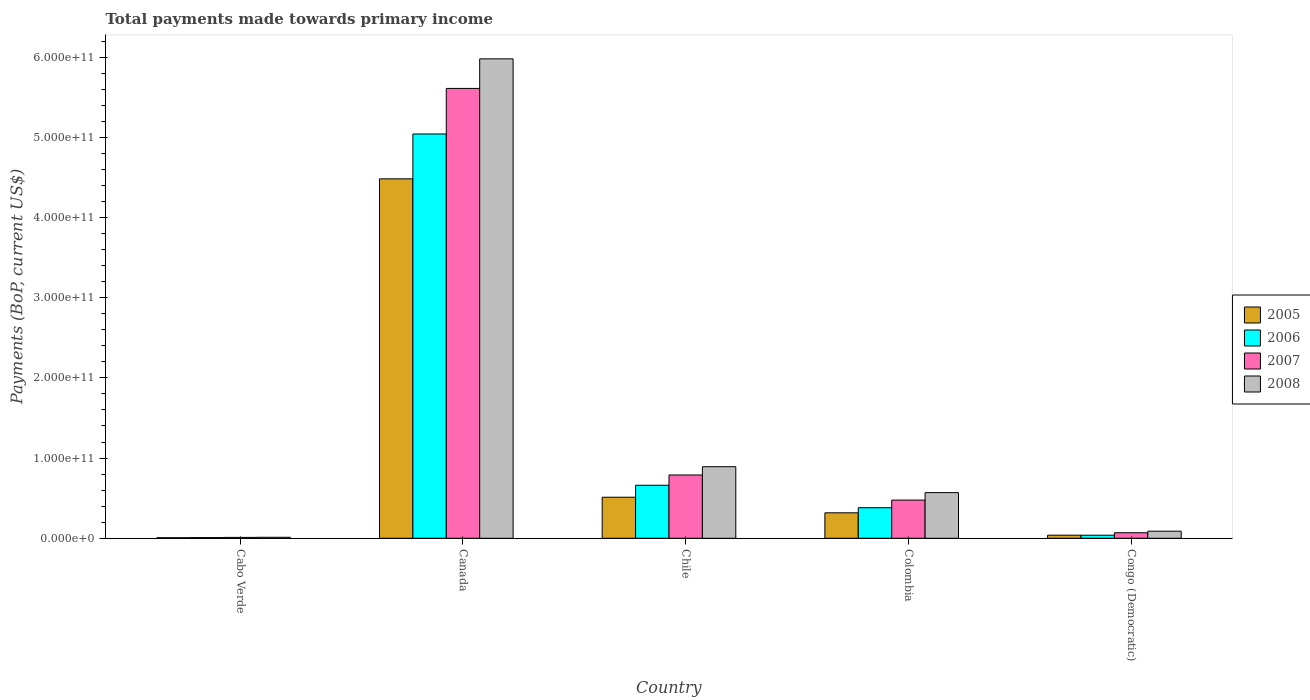How many different coloured bars are there?
Your answer should be very brief. 4. Are the number of bars per tick equal to the number of legend labels?
Ensure brevity in your answer.  Yes. How many bars are there on the 5th tick from the right?
Offer a very short reply. 4. What is the label of the 1st group of bars from the left?
Make the answer very short. Cabo Verde. What is the total payments made towards primary income in 2007 in Canada?
Offer a terse response. 5.61e+11. Across all countries, what is the maximum total payments made towards primary income in 2007?
Offer a very short reply. 5.61e+11. Across all countries, what is the minimum total payments made towards primary income in 2007?
Keep it short and to the point. 1.09e+09. In which country was the total payments made towards primary income in 2008 minimum?
Offer a terse response. Cabo Verde. What is the total total payments made towards primary income in 2005 in the graph?
Keep it short and to the point. 5.36e+11. What is the difference between the total payments made towards primary income in 2007 in Chile and that in Congo (Democratic)?
Your answer should be compact. 7.20e+1. What is the difference between the total payments made towards primary income in 2008 in Cabo Verde and the total payments made towards primary income in 2005 in Congo (Democratic)?
Your answer should be very brief. -2.63e+09. What is the average total payments made towards primary income in 2005 per country?
Keep it short and to the point. 1.07e+11. What is the difference between the total payments made towards primary income of/in 2006 and total payments made towards primary income of/in 2007 in Cabo Verde?
Your response must be concise. -2.29e+08. In how many countries, is the total payments made towards primary income in 2008 greater than 480000000000 US$?
Ensure brevity in your answer.  1. What is the ratio of the total payments made towards primary income in 2005 in Chile to that in Colombia?
Provide a succinct answer. 1.61. Is the total payments made towards primary income in 2006 in Canada less than that in Colombia?
Provide a short and direct response. No. What is the difference between the highest and the second highest total payments made towards primary income in 2006?
Keep it short and to the point. 4.38e+11. What is the difference between the highest and the lowest total payments made towards primary income in 2007?
Make the answer very short. 5.60e+11. In how many countries, is the total payments made towards primary income in 2008 greater than the average total payments made towards primary income in 2008 taken over all countries?
Make the answer very short. 1. What does the 3rd bar from the left in Canada represents?
Ensure brevity in your answer.  2007. What does the 3rd bar from the right in Canada represents?
Keep it short and to the point. 2006. How many bars are there?
Ensure brevity in your answer.  20. What is the difference between two consecutive major ticks on the Y-axis?
Give a very brief answer. 1.00e+11. How many legend labels are there?
Provide a short and direct response. 4. What is the title of the graph?
Provide a succinct answer. Total payments made towards primary income. What is the label or title of the X-axis?
Your answer should be very brief. Country. What is the label or title of the Y-axis?
Ensure brevity in your answer.  Payments (BoP, current US$). What is the Payments (BoP, current US$) in 2005 in Cabo Verde?
Provide a succinct answer. 6.95e+08. What is the Payments (BoP, current US$) of 2006 in Cabo Verde?
Your answer should be compact. 8.63e+08. What is the Payments (BoP, current US$) of 2007 in Cabo Verde?
Your answer should be very brief. 1.09e+09. What is the Payments (BoP, current US$) of 2008 in Cabo Verde?
Ensure brevity in your answer.  1.26e+09. What is the Payments (BoP, current US$) of 2005 in Canada?
Make the answer very short. 4.48e+11. What is the Payments (BoP, current US$) of 2006 in Canada?
Your answer should be very brief. 5.04e+11. What is the Payments (BoP, current US$) in 2007 in Canada?
Give a very brief answer. 5.61e+11. What is the Payments (BoP, current US$) of 2008 in Canada?
Provide a succinct answer. 5.98e+11. What is the Payments (BoP, current US$) in 2005 in Chile?
Your answer should be compact. 5.12e+1. What is the Payments (BoP, current US$) of 2006 in Chile?
Provide a succinct answer. 6.61e+1. What is the Payments (BoP, current US$) of 2007 in Chile?
Offer a very short reply. 7.89e+1. What is the Payments (BoP, current US$) of 2008 in Chile?
Make the answer very short. 8.92e+1. What is the Payments (BoP, current US$) of 2005 in Colombia?
Provide a succinct answer. 3.18e+1. What is the Payments (BoP, current US$) of 2006 in Colombia?
Offer a very short reply. 3.81e+1. What is the Payments (BoP, current US$) of 2007 in Colombia?
Offer a terse response. 4.76e+1. What is the Payments (BoP, current US$) in 2008 in Colombia?
Give a very brief answer. 5.69e+1. What is the Payments (BoP, current US$) in 2005 in Congo (Democratic)?
Your answer should be compact. 3.89e+09. What is the Payments (BoP, current US$) of 2006 in Congo (Democratic)?
Offer a very short reply. 3.83e+09. What is the Payments (BoP, current US$) in 2007 in Congo (Democratic)?
Ensure brevity in your answer.  6.90e+09. What is the Payments (BoP, current US$) in 2008 in Congo (Democratic)?
Provide a succinct answer. 8.86e+09. Across all countries, what is the maximum Payments (BoP, current US$) of 2005?
Ensure brevity in your answer.  4.48e+11. Across all countries, what is the maximum Payments (BoP, current US$) in 2006?
Provide a short and direct response. 5.04e+11. Across all countries, what is the maximum Payments (BoP, current US$) in 2007?
Give a very brief answer. 5.61e+11. Across all countries, what is the maximum Payments (BoP, current US$) in 2008?
Provide a short and direct response. 5.98e+11. Across all countries, what is the minimum Payments (BoP, current US$) in 2005?
Keep it short and to the point. 6.95e+08. Across all countries, what is the minimum Payments (BoP, current US$) of 2006?
Make the answer very short. 8.63e+08. Across all countries, what is the minimum Payments (BoP, current US$) of 2007?
Ensure brevity in your answer.  1.09e+09. Across all countries, what is the minimum Payments (BoP, current US$) of 2008?
Make the answer very short. 1.26e+09. What is the total Payments (BoP, current US$) of 2005 in the graph?
Offer a very short reply. 5.36e+11. What is the total Payments (BoP, current US$) of 2006 in the graph?
Your answer should be very brief. 6.13e+11. What is the total Payments (BoP, current US$) in 2007 in the graph?
Your response must be concise. 6.95e+11. What is the total Payments (BoP, current US$) of 2008 in the graph?
Offer a terse response. 7.54e+11. What is the difference between the Payments (BoP, current US$) in 2005 in Cabo Verde and that in Canada?
Your response must be concise. -4.47e+11. What is the difference between the Payments (BoP, current US$) of 2006 in Cabo Verde and that in Canada?
Make the answer very short. -5.03e+11. What is the difference between the Payments (BoP, current US$) in 2007 in Cabo Verde and that in Canada?
Your answer should be compact. -5.60e+11. What is the difference between the Payments (BoP, current US$) in 2008 in Cabo Verde and that in Canada?
Provide a short and direct response. -5.97e+11. What is the difference between the Payments (BoP, current US$) of 2005 in Cabo Verde and that in Chile?
Make the answer very short. -5.05e+1. What is the difference between the Payments (BoP, current US$) in 2006 in Cabo Verde and that in Chile?
Offer a very short reply. -6.53e+1. What is the difference between the Payments (BoP, current US$) of 2007 in Cabo Verde and that in Chile?
Make the answer very short. -7.78e+1. What is the difference between the Payments (BoP, current US$) of 2008 in Cabo Verde and that in Chile?
Make the answer very short. -8.80e+1. What is the difference between the Payments (BoP, current US$) in 2005 in Cabo Verde and that in Colombia?
Provide a succinct answer. -3.11e+1. What is the difference between the Payments (BoP, current US$) in 2006 in Cabo Verde and that in Colombia?
Give a very brief answer. -3.73e+1. What is the difference between the Payments (BoP, current US$) in 2007 in Cabo Verde and that in Colombia?
Keep it short and to the point. -4.65e+1. What is the difference between the Payments (BoP, current US$) in 2008 in Cabo Verde and that in Colombia?
Your answer should be very brief. -5.57e+1. What is the difference between the Payments (BoP, current US$) in 2005 in Cabo Verde and that in Congo (Democratic)?
Your answer should be very brief. -3.20e+09. What is the difference between the Payments (BoP, current US$) of 2006 in Cabo Verde and that in Congo (Democratic)?
Offer a terse response. -2.97e+09. What is the difference between the Payments (BoP, current US$) in 2007 in Cabo Verde and that in Congo (Democratic)?
Provide a short and direct response. -5.81e+09. What is the difference between the Payments (BoP, current US$) of 2008 in Cabo Verde and that in Congo (Democratic)?
Ensure brevity in your answer.  -7.60e+09. What is the difference between the Payments (BoP, current US$) of 2005 in Canada and that in Chile?
Your answer should be compact. 3.97e+11. What is the difference between the Payments (BoP, current US$) of 2006 in Canada and that in Chile?
Your response must be concise. 4.38e+11. What is the difference between the Payments (BoP, current US$) in 2007 in Canada and that in Chile?
Make the answer very short. 4.82e+11. What is the difference between the Payments (BoP, current US$) in 2008 in Canada and that in Chile?
Provide a short and direct response. 5.09e+11. What is the difference between the Payments (BoP, current US$) of 2005 in Canada and that in Colombia?
Offer a terse response. 4.16e+11. What is the difference between the Payments (BoP, current US$) in 2006 in Canada and that in Colombia?
Your answer should be compact. 4.66e+11. What is the difference between the Payments (BoP, current US$) of 2007 in Canada and that in Colombia?
Offer a terse response. 5.13e+11. What is the difference between the Payments (BoP, current US$) of 2008 in Canada and that in Colombia?
Make the answer very short. 5.41e+11. What is the difference between the Payments (BoP, current US$) of 2005 in Canada and that in Congo (Democratic)?
Provide a succinct answer. 4.44e+11. What is the difference between the Payments (BoP, current US$) of 2006 in Canada and that in Congo (Democratic)?
Ensure brevity in your answer.  5.00e+11. What is the difference between the Payments (BoP, current US$) in 2007 in Canada and that in Congo (Democratic)?
Offer a very short reply. 5.54e+11. What is the difference between the Payments (BoP, current US$) of 2008 in Canada and that in Congo (Democratic)?
Provide a succinct answer. 5.89e+11. What is the difference between the Payments (BoP, current US$) in 2005 in Chile and that in Colombia?
Give a very brief answer. 1.94e+1. What is the difference between the Payments (BoP, current US$) of 2006 in Chile and that in Colombia?
Provide a short and direct response. 2.80e+1. What is the difference between the Payments (BoP, current US$) of 2007 in Chile and that in Colombia?
Ensure brevity in your answer.  3.13e+1. What is the difference between the Payments (BoP, current US$) in 2008 in Chile and that in Colombia?
Provide a succinct answer. 3.23e+1. What is the difference between the Payments (BoP, current US$) of 2005 in Chile and that in Congo (Democratic)?
Make the answer very short. 4.73e+1. What is the difference between the Payments (BoP, current US$) in 2006 in Chile and that in Congo (Democratic)?
Your answer should be very brief. 6.23e+1. What is the difference between the Payments (BoP, current US$) of 2007 in Chile and that in Congo (Democratic)?
Offer a terse response. 7.20e+1. What is the difference between the Payments (BoP, current US$) of 2008 in Chile and that in Congo (Democratic)?
Keep it short and to the point. 8.04e+1. What is the difference between the Payments (BoP, current US$) in 2005 in Colombia and that in Congo (Democratic)?
Provide a short and direct response. 2.79e+1. What is the difference between the Payments (BoP, current US$) of 2006 in Colombia and that in Congo (Democratic)?
Provide a short and direct response. 3.43e+1. What is the difference between the Payments (BoP, current US$) in 2007 in Colombia and that in Congo (Democratic)?
Your answer should be compact. 4.07e+1. What is the difference between the Payments (BoP, current US$) in 2008 in Colombia and that in Congo (Democratic)?
Offer a terse response. 4.81e+1. What is the difference between the Payments (BoP, current US$) in 2005 in Cabo Verde and the Payments (BoP, current US$) in 2006 in Canada?
Provide a succinct answer. -5.03e+11. What is the difference between the Payments (BoP, current US$) in 2005 in Cabo Verde and the Payments (BoP, current US$) in 2007 in Canada?
Your answer should be very brief. -5.60e+11. What is the difference between the Payments (BoP, current US$) in 2005 in Cabo Verde and the Payments (BoP, current US$) in 2008 in Canada?
Your response must be concise. -5.97e+11. What is the difference between the Payments (BoP, current US$) of 2006 in Cabo Verde and the Payments (BoP, current US$) of 2007 in Canada?
Give a very brief answer. -5.60e+11. What is the difference between the Payments (BoP, current US$) of 2006 in Cabo Verde and the Payments (BoP, current US$) of 2008 in Canada?
Make the answer very short. -5.97e+11. What is the difference between the Payments (BoP, current US$) in 2007 in Cabo Verde and the Payments (BoP, current US$) in 2008 in Canada?
Keep it short and to the point. -5.97e+11. What is the difference between the Payments (BoP, current US$) in 2005 in Cabo Verde and the Payments (BoP, current US$) in 2006 in Chile?
Give a very brief answer. -6.54e+1. What is the difference between the Payments (BoP, current US$) of 2005 in Cabo Verde and the Payments (BoP, current US$) of 2007 in Chile?
Provide a succinct answer. -7.82e+1. What is the difference between the Payments (BoP, current US$) of 2005 in Cabo Verde and the Payments (BoP, current US$) of 2008 in Chile?
Your answer should be very brief. -8.86e+1. What is the difference between the Payments (BoP, current US$) of 2006 in Cabo Verde and the Payments (BoP, current US$) of 2007 in Chile?
Make the answer very short. -7.81e+1. What is the difference between the Payments (BoP, current US$) of 2006 in Cabo Verde and the Payments (BoP, current US$) of 2008 in Chile?
Ensure brevity in your answer.  -8.84e+1. What is the difference between the Payments (BoP, current US$) of 2007 in Cabo Verde and the Payments (BoP, current US$) of 2008 in Chile?
Make the answer very short. -8.82e+1. What is the difference between the Payments (BoP, current US$) of 2005 in Cabo Verde and the Payments (BoP, current US$) of 2006 in Colombia?
Provide a short and direct response. -3.74e+1. What is the difference between the Payments (BoP, current US$) of 2005 in Cabo Verde and the Payments (BoP, current US$) of 2007 in Colombia?
Provide a succinct answer. -4.69e+1. What is the difference between the Payments (BoP, current US$) in 2005 in Cabo Verde and the Payments (BoP, current US$) in 2008 in Colombia?
Your answer should be very brief. -5.62e+1. What is the difference between the Payments (BoP, current US$) in 2006 in Cabo Verde and the Payments (BoP, current US$) in 2007 in Colombia?
Offer a very short reply. -4.68e+1. What is the difference between the Payments (BoP, current US$) in 2006 in Cabo Verde and the Payments (BoP, current US$) in 2008 in Colombia?
Give a very brief answer. -5.61e+1. What is the difference between the Payments (BoP, current US$) in 2007 in Cabo Verde and the Payments (BoP, current US$) in 2008 in Colombia?
Your answer should be very brief. -5.58e+1. What is the difference between the Payments (BoP, current US$) of 2005 in Cabo Verde and the Payments (BoP, current US$) of 2006 in Congo (Democratic)?
Your response must be concise. -3.13e+09. What is the difference between the Payments (BoP, current US$) in 2005 in Cabo Verde and the Payments (BoP, current US$) in 2007 in Congo (Democratic)?
Your response must be concise. -6.21e+09. What is the difference between the Payments (BoP, current US$) in 2005 in Cabo Verde and the Payments (BoP, current US$) in 2008 in Congo (Democratic)?
Your answer should be compact. -8.17e+09. What is the difference between the Payments (BoP, current US$) in 2006 in Cabo Verde and the Payments (BoP, current US$) in 2007 in Congo (Democratic)?
Provide a short and direct response. -6.04e+09. What is the difference between the Payments (BoP, current US$) of 2006 in Cabo Verde and the Payments (BoP, current US$) of 2008 in Congo (Democratic)?
Offer a terse response. -8.00e+09. What is the difference between the Payments (BoP, current US$) in 2007 in Cabo Verde and the Payments (BoP, current US$) in 2008 in Congo (Democratic)?
Your answer should be compact. -7.77e+09. What is the difference between the Payments (BoP, current US$) in 2005 in Canada and the Payments (BoP, current US$) in 2006 in Chile?
Ensure brevity in your answer.  3.82e+11. What is the difference between the Payments (BoP, current US$) in 2005 in Canada and the Payments (BoP, current US$) in 2007 in Chile?
Offer a very short reply. 3.69e+11. What is the difference between the Payments (BoP, current US$) of 2005 in Canada and the Payments (BoP, current US$) of 2008 in Chile?
Your response must be concise. 3.59e+11. What is the difference between the Payments (BoP, current US$) in 2006 in Canada and the Payments (BoP, current US$) in 2007 in Chile?
Your answer should be very brief. 4.25e+11. What is the difference between the Payments (BoP, current US$) of 2006 in Canada and the Payments (BoP, current US$) of 2008 in Chile?
Ensure brevity in your answer.  4.15e+11. What is the difference between the Payments (BoP, current US$) in 2007 in Canada and the Payments (BoP, current US$) in 2008 in Chile?
Keep it short and to the point. 4.72e+11. What is the difference between the Payments (BoP, current US$) of 2005 in Canada and the Payments (BoP, current US$) of 2006 in Colombia?
Offer a very short reply. 4.10e+11. What is the difference between the Payments (BoP, current US$) of 2005 in Canada and the Payments (BoP, current US$) of 2007 in Colombia?
Your response must be concise. 4.01e+11. What is the difference between the Payments (BoP, current US$) of 2005 in Canada and the Payments (BoP, current US$) of 2008 in Colombia?
Make the answer very short. 3.91e+11. What is the difference between the Payments (BoP, current US$) of 2006 in Canada and the Payments (BoP, current US$) of 2007 in Colombia?
Your response must be concise. 4.56e+11. What is the difference between the Payments (BoP, current US$) of 2006 in Canada and the Payments (BoP, current US$) of 2008 in Colombia?
Ensure brevity in your answer.  4.47e+11. What is the difference between the Payments (BoP, current US$) of 2007 in Canada and the Payments (BoP, current US$) of 2008 in Colombia?
Your response must be concise. 5.04e+11. What is the difference between the Payments (BoP, current US$) of 2005 in Canada and the Payments (BoP, current US$) of 2006 in Congo (Democratic)?
Offer a terse response. 4.44e+11. What is the difference between the Payments (BoP, current US$) in 2005 in Canada and the Payments (BoP, current US$) in 2007 in Congo (Democratic)?
Your answer should be very brief. 4.41e+11. What is the difference between the Payments (BoP, current US$) of 2005 in Canada and the Payments (BoP, current US$) of 2008 in Congo (Democratic)?
Your answer should be compact. 4.39e+11. What is the difference between the Payments (BoP, current US$) in 2006 in Canada and the Payments (BoP, current US$) in 2007 in Congo (Democratic)?
Your response must be concise. 4.97e+11. What is the difference between the Payments (BoP, current US$) in 2006 in Canada and the Payments (BoP, current US$) in 2008 in Congo (Democratic)?
Make the answer very short. 4.95e+11. What is the difference between the Payments (BoP, current US$) of 2007 in Canada and the Payments (BoP, current US$) of 2008 in Congo (Democratic)?
Your answer should be very brief. 5.52e+11. What is the difference between the Payments (BoP, current US$) in 2005 in Chile and the Payments (BoP, current US$) in 2006 in Colombia?
Provide a succinct answer. 1.31e+1. What is the difference between the Payments (BoP, current US$) of 2005 in Chile and the Payments (BoP, current US$) of 2007 in Colombia?
Keep it short and to the point. 3.56e+09. What is the difference between the Payments (BoP, current US$) of 2005 in Chile and the Payments (BoP, current US$) of 2008 in Colombia?
Keep it short and to the point. -5.74e+09. What is the difference between the Payments (BoP, current US$) in 2006 in Chile and the Payments (BoP, current US$) in 2007 in Colombia?
Provide a succinct answer. 1.85e+1. What is the difference between the Payments (BoP, current US$) in 2006 in Chile and the Payments (BoP, current US$) in 2008 in Colombia?
Your response must be concise. 9.21e+09. What is the difference between the Payments (BoP, current US$) in 2007 in Chile and the Payments (BoP, current US$) in 2008 in Colombia?
Provide a short and direct response. 2.20e+1. What is the difference between the Payments (BoP, current US$) of 2005 in Chile and the Payments (BoP, current US$) of 2006 in Congo (Democratic)?
Offer a very short reply. 4.74e+1. What is the difference between the Payments (BoP, current US$) in 2005 in Chile and the Payments (BoP, current US$) in 2007 in Congo (Democratic)?
Provide a short and direct response. 4.43e+1. What is the difference between the Payments (BoP, current US$) in 2005 in Chile and the Payments (BoP, current US$) in 2008 in Congo (Democratic)?
Offer a very short reply. 4.23e+1. What is the difference between the Payments (BoP, current US$) of 2006 in Chile and the Payments (BoP, current US$) of 2007 in Congo (Democratic)?
Keep it short and to the point. 5.92e+1. What is the difference between the Payments (BoP, current US$) in 2006 in Chile and the Payments (BoP, current US$) in 2008 in Congo (Democratic)?
Keep it short and to the point. 5.73e+1. What is the difference between the Payments (BoP, current US$) in 2007 in Chile and the Payments (BoP, current US$) in 2008 in Congo (Democratic)?
Offer a very short reply. 7.01e+1. What is the difference between the Payments (BoP, current US$) in 2005 in Colombia and the Payments (BoP, current US$) in 2006 in Congo (Democratic)?
Provide a short and direct response. 2.79e+1. What is the difference between the Payments (BoP, current US$) in 2005 in Colombia and the Payments (BoP, current US$) in 2007 in Congo (Democratic)?
Make the answer very short. 2.49e+1. What is the difference between the Payments (BoP, current US$) in 2005 in Colombia and the Payments (BoP, current US$) in 2008 in Congo (Democratic)?
Give a very brief answer. 2.29e+1. What is the difference between the Payments (BoP, current US$) of 2006 in Colombia and the Payments (BoP, current US$) of 2007 in Congo (Democratic)?
Provide a short and direct response. 3.12e+1. What is the difference between the Payments (BoP, current US$) in 2006 in Colombia and the Payments (BoP, current US$) in 2008 in Congo (Democratic)?
Offer a very short reply. 2.93e+1. What is the difference between the Payments (BoP, current US$) of 2007 in Colombia and the Payments (BoP, current US$) of 2008 in Congo (Democratic)?
Your answer should be compact. 3.88e+1. What is the average Payments (BoP, current US$) in 2005 per country?
Provide a short and direct response. 1.07e+11. What is the average Payments (BoP, current US$) of 2006 per country?
Your answer should be compact. 1.23e+11. What is the average Payments (BoP, current US$) of 2007 per country?
Ensure brevity in your answer.  1.39e+11. What is the average Payments (BoP, current US$) in 2008 per country?
Make the answer very short. 1.51e+11. What is the difference between the Payments (BoP, current US$) of 2005 and Payments (BoP, current US$) of 2006 in Cabo Verde?
Offer a very short reply. -1.69e+08. What is the difference between the Payments (BoP, current US$) in 2005 and Payments (BoP, current US$) in 2007 in Cabo Verde?
Offer a very short reply. -3.98e+08. What is the difference between the Payments (BoP, current US$) in 2005 and Payments (BoP, current US$) in 2008 in Cabo Verde?
Offer a very short reply. -5.64e+08. What is the difference between the Payments (BoP, current US$) of 2006 and Payments (BoP, current US$) of 2007 in Cabo Verde?
Make the answer very short. -2.29e+08. What is the difference between the Payments (BoP, current US$) in 2006 and Payments (BoP, current US$) in 2008 in Cabo Verde?
Offer a very short reply. -3.96e+08. What is the difference between the Payments (BoP, current US$) in 2007 and Payments (BoP, current US$) in 2008 in Cabo Verde?
Give a very brief answer. -1.66e+08. What is the difference between the Payments (BoP, current US$) of 2005 and Payments (BoP, current US$) of 2006 in Canada?
Your response must be concise. -5.59e+1. What is the difference between the Payments (BoP, current US$) in 2005 and Payments (BoP, current US$) in 2007 in Canada?
Provide a short and direct response. -1.13e+11. What is the difference between the Payments (BoP, current US$) of 2005 and Payments (BoP, current US$) of 2008 in Canada?
Provide a short and direct response. -1.50e+11. What is the difference between the Payments (BoP, current US$) in 2006 and Payments (BoP, current US$) in 2007 in Canada?
Provide a succinct answer. -5.68e+1. What is the difference between the Payments (BoP, current US$) in 2006 and Payments (BoP, current US$) in 2008 in Canada?
Your response must be concise. -9.37e+1. What is the difference between the Payments (BoP, current US$) in 2007 and Payments (BoP, current US$) in 2008 in Canada?
Offer a very short reply. -3.69e+1. What is the difference between the Payments (BoP, current US$) of 2005 and Payments (BoP, current US$) of 2006 in Chile?
Your answer should be compact. -1.49e+1. What is the difference between the Payments (BoP, current US$) of 2005 and Payments (BoP, current US$) of 2007 in Chile?
Your response must be concise. -2.77e+1. What is the difference between the Payments (BoP, current US$) of 2005 and Payments (BoP, current US$) of 2008 in Chile?
Your response must be concise. -3.81e+1. What is the difference between the Payments (BoP, current US$) in 2006 and Payments (BoP, current US$) in 2007 in Chile?
Make the answer very short. -1.28e+1. What is the difference between the Payments (BoP, current US$) of 2006 and Payments (BoP, current US$) of 2008 in Chile?
Your response must be concise. -2.31e+1. What is the difference between the Payments (BoP, current US$) in 2007 and Payments (BoP, current US$) in 2008 in Chile?
Provide a succinct answer. -1.03e+1. What is the difference between the Payments (BoP, current US$) in 2005 and Payments (BoP, current US$) in 2006 in Colombia?
Provide a succinct answer. -6.36e+09. What is the difference between the Payments (BoP, current US$) in 2005 and Payments (BoP, current US$) in 2007 in Colombia?
Your response must be concise. -1.59e+1. What is the difference between the Payments (BoP, current US$) of 2005 and Payments (BoP, current US$) of 2008 in Colombia?
Provide a short and direct response. -2.52e+1. What is the difference between the Payments (BoP, current US$) of 2006 and Payments (BoP, current US$) of 2007 in Colombia?
Your response must be concise. -9.51e+09. What is the difference between the Payments (BoP, current US$) in 2006 and Payments (BoP, current US$) in 2008 in Colombia?
Ensure brevity in your answer.  -1.88e+1. What is the difference between the Payments (BoP, current US$) of 2007 and Payments (BoP, current US$) of 2008 in Colombia?
Provide a short and direct response. -9.30e+09. What is the difference between the Payments (BoP, current US$) in 2005 and Payments (BoP, current US$) in 2006 in Congo (Democratic)?
Provide a succinct answer. 6.30e+07. What is the difference between the Payments (BoP, current US$) in 2005 and Payments (BoP, current US$) in 2007 in Congo (Democratic)?
Give a very brief answer. -3.01e+09. What is the difference between the Payments (BoP, current US$) of 2005 and Payments (BoP, current US$) of 2008 in Congo (Democratic)?
Provide a succinct answer. -4.97e+09. What is the difference between the Payments (BoP, current US$) in 2006 and Payments (BoP, current US$) in 2007 in Congo (Democratic)?
Your response must be concise. -3.07e+09. What is the difference between the Payments (BoP, current US$) of 2006 and Payments (BoP, current US$) of 2008 in Congo (Democratic)?
Provide a succinct answer. -5.03e+09. What is the difference between the Payments (BoP, current US$) of 2007 and Payments (BoP, current US$) of 2008 in Congo (Democratic)?
Ensure brevity in your answer.  -1.96e+09. What is the ratio of the Payments (BoP, current US$) in 2005 in Cabo Verde to that in Canada?
Your answer should be very brief. 0. What is the ratio of the Payments (BoP, current US$) in 2006 in Cabo Verde to that in Canada?
Provide a short and direct response. 0. What is the ratio of the Payments (BoP, current US$) of 2007 in Cabo Verde to that in Canada?
Give a very brief answer. 0. What is the ratio of the Payments (BoP, current US$) of 2008 in Cabo Verde to that in Canada?
Make the answer very short. 0. What is the ratio of the Payments (BoP, current US$) in 2005 in Cabo Verde to that in Chile?
Provide a succinct answer. 0.01. What is the ratio of the Payments (BoP, current US$) in 2006 in Cabo Verde to that in Chile?
Provide a short and direct response. 0.01. What is the ratio of the Payments (BoP, current US$) in 2007 in Cabo Verde to that in Chile?
Keep it short and to the point. 0.01. What is the ratio of the Payments (BoP, current US$) in 2008 in Cabo Verde to that in Chile?
Your answer should be compact. 0.01. What is the ratio of the Payments (BoP, current US$) in 2005 in Cabo Verde to that in Colombia?
Your answer should be compact. 0.02. What is the ratio of the Payments (BoP, current US$) of 2006 in Cabo Verde to that in Colombia?
Provide a short and direct response. 0.02. What is the ratio of the Payments (BoP, current US$) of 2007 in Cabo Verde to that in Colombia?
Provide a succinct answer. 0.02. What is the ratio of the Payments (BoP, current US$) in 2008 in Cabo Verde to that in Colombia?
Your response must be concise. 0.02. What is the ratio of the Payments (BoP, current US$) in 2005 in Cabo Verde to that in Congo (Democratic)?
Give a very brief answer. 0.18. What is the ratio of the Payments (BoP, current US$) of 2006 in Cabo Verde to that in Congo (Democratic)?
Provide a succinct answer. 0.23. What is the ratio of the Payments (BoP, current US$) in 2007 in Cabo Verde to that in Congo (Democratic)?
Provide a short and direct response. 0.16. What is the ratio of the Payments (BoP, current US$) of 2008 in Cabo Verde to that in Congo (Democratic)?
Make the answer very short. 0.14. What is the ratio of the Payments (BoP, current US$) in 2005 in Canada to that in Chile?
Your answer should be compact. 8.76. What is the ratio of the Payments (BoP, current US$) in 2006 in Canada to that in Chile?
Provide a succinct answer. 7.62. What is the ratio of the Payments (BoP, current US$) of 2007 in Canada to that in Chile?
Give a very brief answer. 7.11. What is the ratio of the Payments (BoP, current US$) in 2008 in Canada to that in Chile?
Give a very brief answer. 6.7. What is the ratio of the Payments (BoP, current US$) of 2005 in Canada to that in Colombia?
Offer a terse response. 14.11. What is the ratio of the Payments (BoP, current US$) in 2006 in Canada to that in Colombia?
Offer a very short reply. 13.22. What is the ratio of the Payments (BoP, current US$) in 2007 in Canada to that in Colombia?
Your answer should be very brief. 11.78. What is the ratio of the Payments (BoP, current US$) in 2008 in Canada to that in Colombia?
Offer a terse response. 10.5. What is the ratio of the Payments (BoP, current US$) in 2005 in Canada to that in Congo (Democratic)?
Offer a terse response. 115.15. What is the ratio of the Payments (BoP, current US$) of 2006 in Canada to that in Congo (Democratic)?
Give a very brief answer. 131.65. What is the ratio of the Payments (BoP, current US$) in 2007 in Canada to that in Congo (Democratic)?
Provide a short and direct response. 81.27. What is the ratio of the Payments (BoP, current US$) of 2008 in Canada to that in Congo (Democratic)?
Your response must be concise. 67.45. What is the ratio of the Payments (BoP, current US$) in 2005 in Chile to that in Colombia?
Provide a succinct answer. 1.61. What is the ratio of the Payments (BoP, current US$) in 2006 in Chile to that in Colombia?
Your answer should be very brief. 1.74. What is the ratio of the Payments (BoP, current US$) of 2007 in Chile to that in Colombia?
Provide a succinct answer. 1.66. What is the ratio of the Payments (BoP, current US$) in 2008 in Chile to that in Colombia?
Your answer should be compact. 1.57. What is the ratio of the Payments (BoP, current US$) in 2005 in Chile to that in Congo (Democratic)?
Make the answer very short. 13.15. What is the ratio of the Payments (BoP, current US$) of 2006 in Chile to that in Congo (Democratic)?
Provide a succinct answer. 17.27. What is the ratio of the Payments (BoP, current US$) of 2007 in Chile to that in Congo (Democratic)?
Your response must be concise. 11.44. What is the ratio of the Payments (BoP, current US$) in 2008 in Chile to that in Congo (Democratic)?
Your answer should be compact. 10.07. What is the ratio of the Payments (BoP, current US$) in 2005 in Colombia to that in Congo (Democratic)?
Provide a short and direct response. 8.16. What is the ratio of the Payments (BoP, current US$) of 2006 in Colombia to that in Congo (Democratic)?
Offer a very short reply. 9.96. What is the ratio of the Payments (BoP, current US$) of 2007 in Colombia to that in Congo (Democratic)?
Make the answer very short. 6.9. What is the ratio of the Payments (BoP, current US$) in 2008 in Colombia to that in Congo (Democratic)?
Your answer should be compact. 6.42. What is the difference between the highest and the second highest Payments (BoP, current US$) in 2005?
Provide a short and direct response. 3.97e+11. What is the difference between the highest and the second highest Payments (BoP, current US$) in 2006?
Make the answer very short. 4.38e+11. What is the difference between the highest and the second highest Payments (BoP, current US$) in 2007?
Keep it short and to the point. 4.82e+11. What is the difference between the highest and the second highest Payments (BoP, current US$) of 2008?
Provide a short and direct response. 5.09e+11. What is the difference between the highest and the lowest Payments (BoP, current US$) of 2005?
Give a very brief answer. 4.47e+11. What is the difference between the highest and the lowest Payments (BoP, current US$) in 2006?
Provide a succinct answer. 5.03e+11. What is the difference between the highest and the lowest Payments (BoP, current US$) of 2007?
Your answer should be compact. 5.60e+11. What is the difference between the highest and the lowest Payments (BoP, current US$) of 2008?
Your response must be concise. 5.97e+11. 